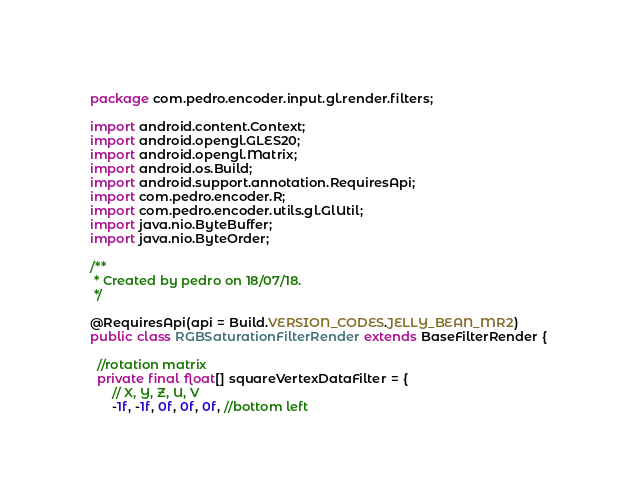<code> <loc_0><loc_0><loc_500><loc_500><_Java_>package com.pedro.encoder.input.gl.render.filters;

import android.content.Context;
import android.opengl.GLES20;
import android.opengl.Matrix;
import android.os.Build;
import android.support.annotation.RequiresApi;
import com.pedro.encoder.R;
import com.pedro.encoder.utils.gl.GlUtil;
import java.nio.ByteBuffer;
import java.nio.ByteOrder;

/**
 * Created by pedro on 18/07/18.
 */

@RequiresApi(api = Build.VERSION_CODES.JELLY_BEAN_MR2)
public class RGBSaturationFilterRender extends BaseFilterRender {

  //rotation matrix
  private final float[] squareVertexDataFilter = {
      // X, Y, Z, U, V
      -1f, -1f, 0f, 0f, 0f, //bottom left</code> 